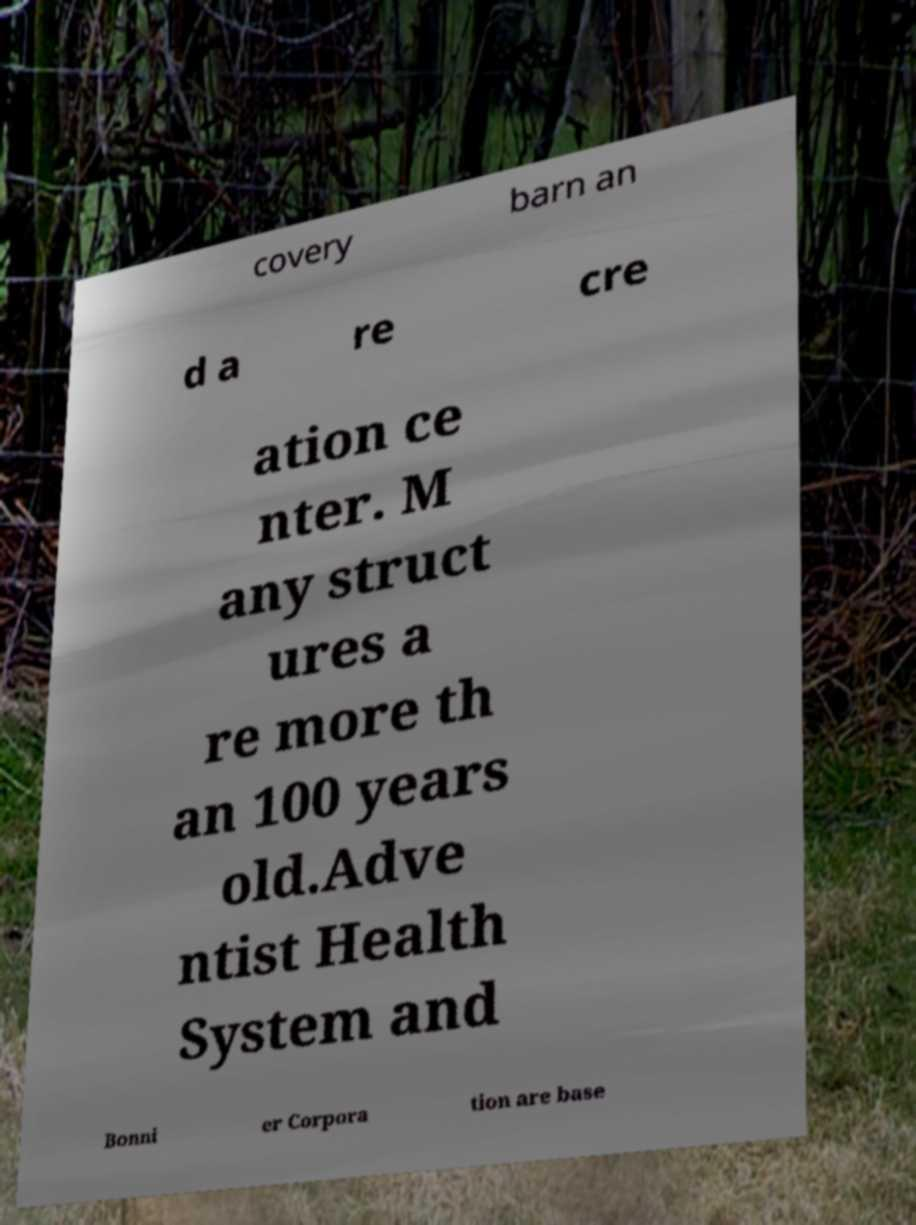Please identify and transcribe the text found in this image. covery barn an d a re cre ation ce nter. M any struct ures a re more th an 100 years old.Adve ntist Health System and Bonni er Corpora tion are base 